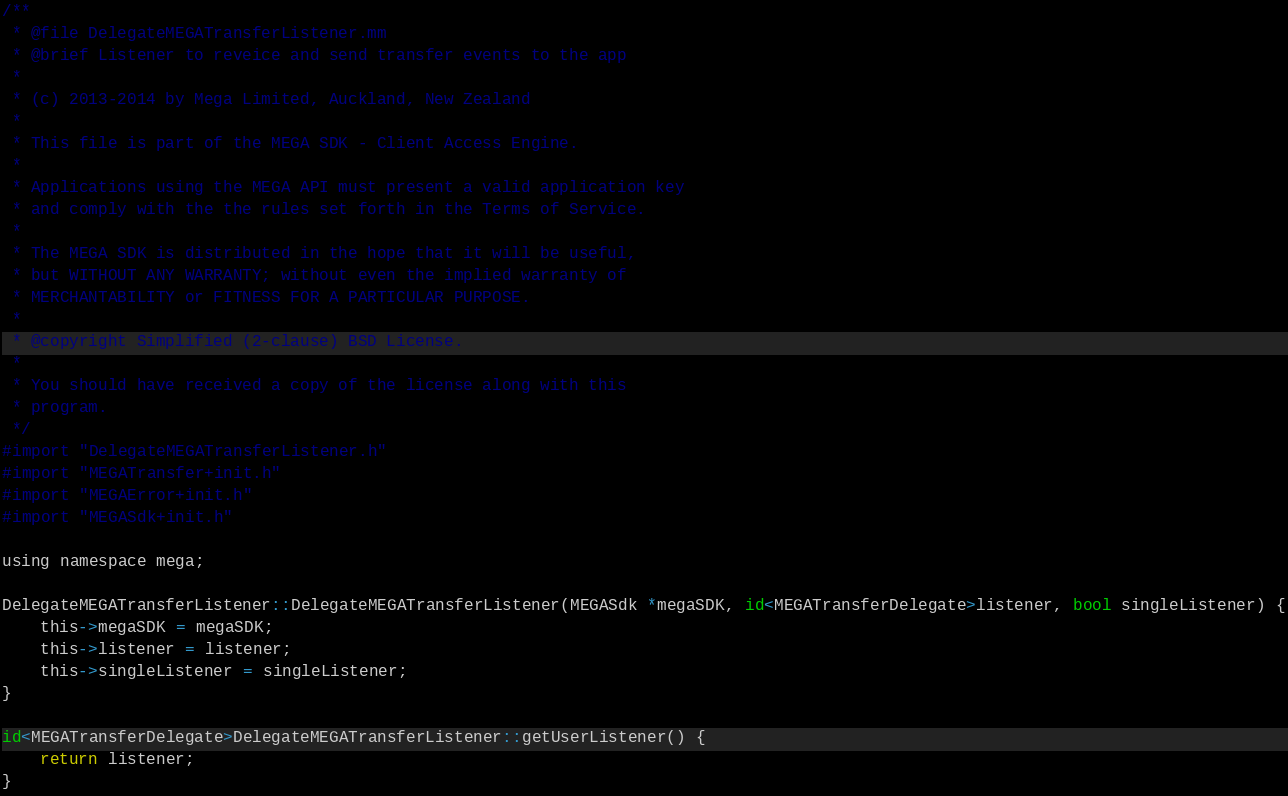Convert code to text. <code><loc_0><loc_0><loc_500><loc_500><_ObjectiveC_>/**
 * @file DelegateMEGATransferListener.mm
 * @brief Listener to reveice and send transfer events to the app
 *
 * (c) 2013-2014 by Mega Limited, Auckland, New Zealand
 *
 * This file is part of the MEGA SDK - Client Access Engine.
 *
 * Applications using the MEGA API must present a valid application key
 * and comply with the the rules set forth in the Terms of Service.
 *
 * The MEGA SDK is distributed in the hope that it will be useful,
 * but WITHOUT ANY WARRANTY; without even the implied warranty of
 * MERCHANTABILITY or FITNESS FOR A PARTICULAR PURPOSE.
 *
 * @copyright Simplified (2-clause) BSD License.
 *
 * You should have received a copy of the license along with this
 * program.
 */
#import "DelegateMEGATransferListener.h"
#import "MEGATransfer+init.h"
#import "MEGAError+init.h"
#import "MEGASdk+init.h"

using namespace mega;

DelegateMEGATransferListener::DelegateMEGATransferListener(MEGASdk *megaSDK, id<MEGATransferDelegate>listener, bool singleListener) {
    this->megaSDK = megaSDK;
    this->listener = listener;
    this->singleListener = singleListener;
}

id<MEGATransferDelegate>DelegateMEGATransferListener::getUserListener() {
    return listener;
}
</code> 